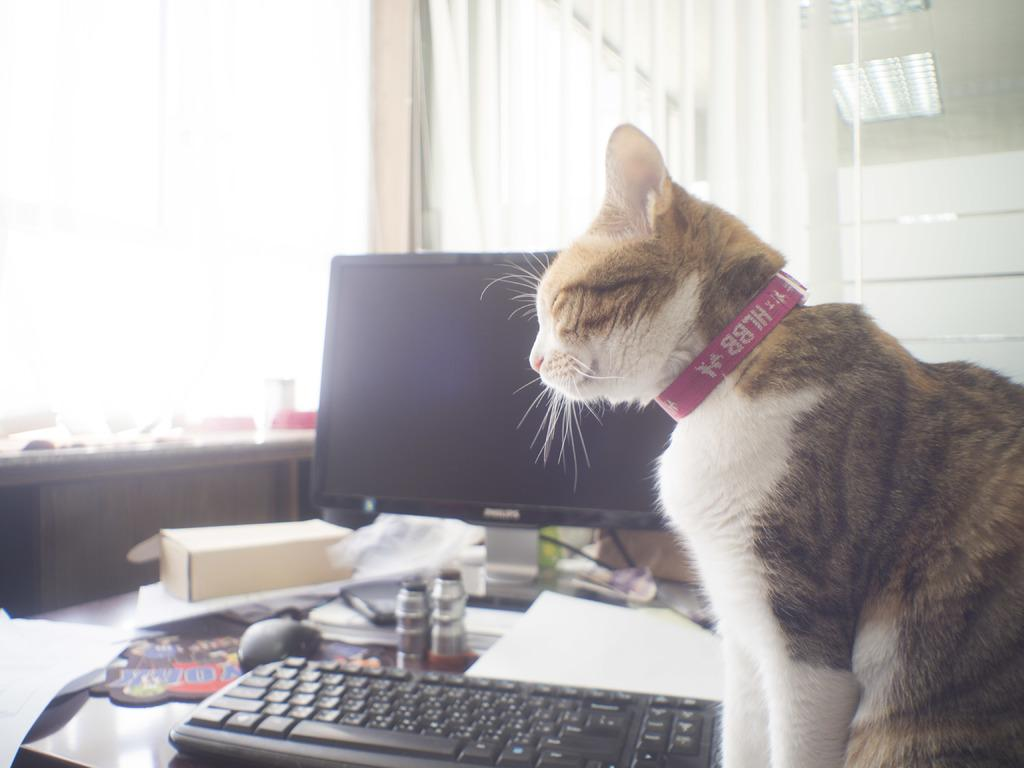What type of animal can be seen in the image? There is a cat in the image. What electronic device is present in the image? There is a keyboard and a monitor in the image. What computer peripheral is visible in the image? There is a mouse in the image. What items related to reading or writing can be seen in the image? There are books and papers in the image. Where are all these objects located? All of these objects are present on a table. What type of turkey is being served on the table in the image? There is no turkey present in the image; it features a cat, a keyboard, a monitor, a mouse, books, and papers on a table. Is the person in the image reading a book? There is no person present in the image, so it is not possible to determine if someone is reading a book. 